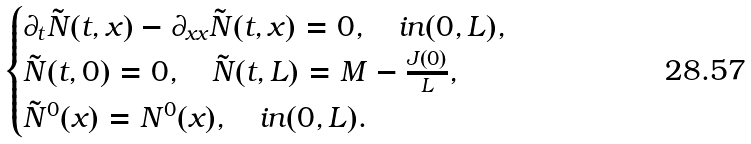<formula> <loc_0><loc_0><loc_500><loc_500>\begin{cases} \partial _ { t } \tilde { N } ( t , x ) - \partial _ { x x } \tilde { N } ( t , x ) = 0 , \quad i n ( 0 , L ) , \\ \tilde { N } ( t , 0 ) = 0 , \quad \tilde { N } ( t , L ) = M - \frac { J ( 0 ) } { L } , \\ \tilde { N } ^ { 0 } ( x ) = N ^ { 0 } ( x ) , \quad i n ( 0 , L ) . \end{cases}</formula> 